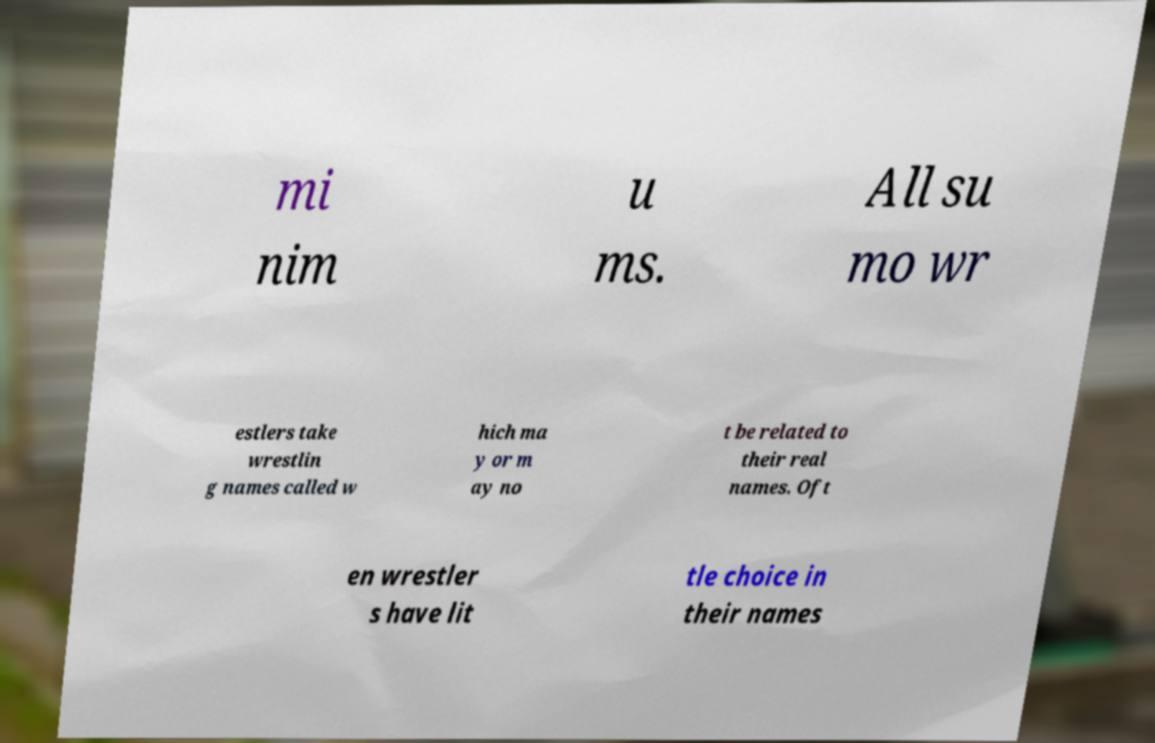I need the written content from this picture converted into text. Can you do that? mi nim u ms. All su mo wr estlers take wrestlin g names called w hich ma y or m ay no t be related to their real names. Oft en wrestler s have lit tle choice in their names 